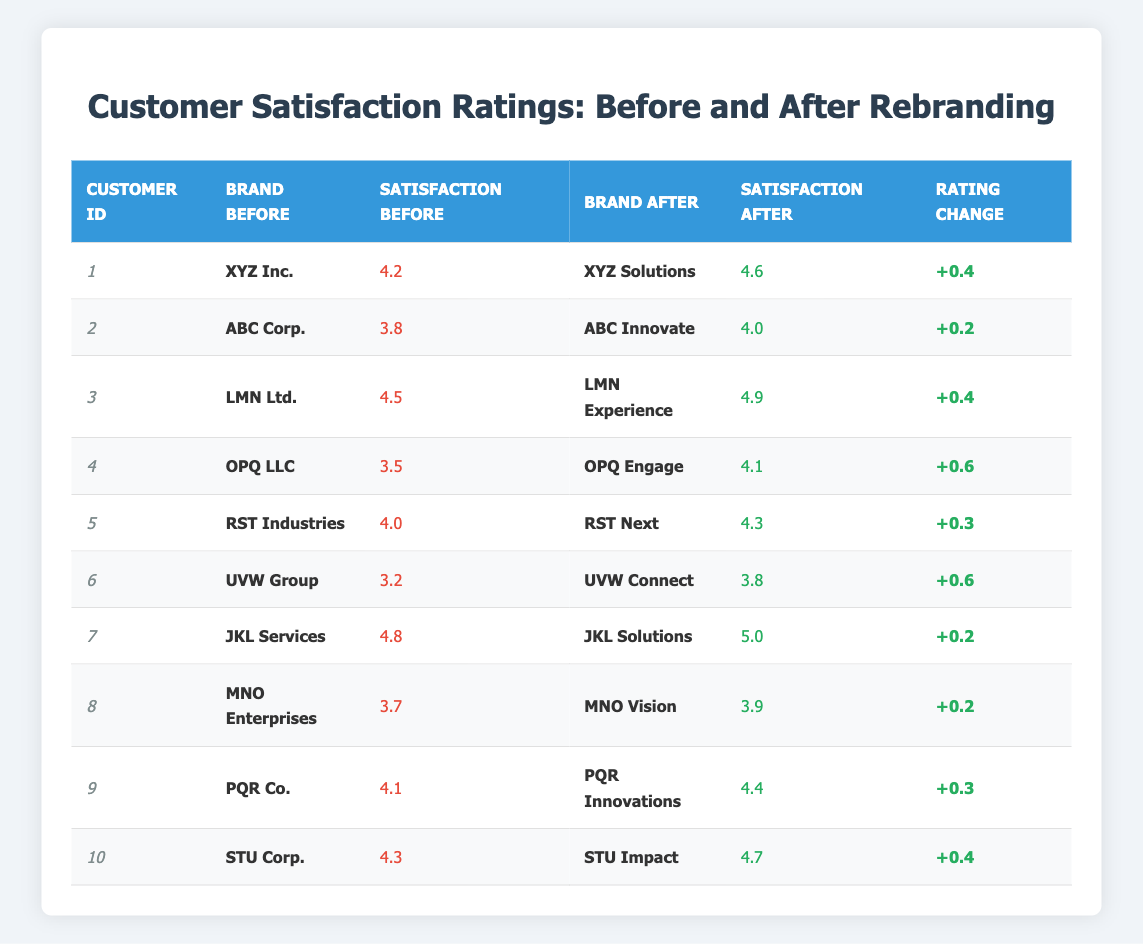What was the highest satisfaction rating before rebranding? The highest satisfaction rating before rebranding can be found by looking at the "Satisfaction Rating Before" column. Scanning through the values, the highest is 4.8 (Customer 7).
Answer: 4.8 What was the brand after rebranding for Customer 4? The table shows the brand before and after rebranding, and for Customer 4, the brand after rebranding is "OPQ Engage."
Answer: OPQ Engage How many customers had a satisfaction rating increase greater than 0.3? To find this, we look at the "Rating Change" column. The changes greater than 0.3 are for Customers 1, 3, 4, 5, 6, 9, and 10, making a total of 7 customers.
Answer: 7 Is there any customer whose satisfaction rating decreased after rebranding? We need to check the "Satisfaction Rating After" against "Satisfaction Rating Before." Customer 6 has a decrease from 3.2 to 3.8, showing a positive change, indicating no customer had a decrease.
Answer: No What is the average satisfaction rating before rebranding? We sum all the satisfaction ratings before rebranding: (4.2 + 3.8 + 4.5 + 3.5 + 4.0 + 3.2 + 4.8 + 3.7 + 4.1 + 4.3) = 43.1. Dividing by 10 customers gives us an average of 4.31.
Answer: 4.31 What was the rating change for the customer with the lowest rating before rebranding? The customer with the lowest rating before rebranding is Customer 6, who had a rating of 3.2. The change for this customer, as per the "Rating Change" column, is +0.6.
Answer: +0.6 How much did Customer 5's satisfaction rating increase? For Customer 5, the satisfaction rating before rebranding was 4.0 and after it became 4.3. The change is calculated as 4.3 - 4.0 = 0.3.
Answer: 0.3 Which brand after rebranding had the highest satisfaction rating? We refer to the "Satisfaction Rating After" column and find the highest value, which is 5.0 for "JKL Solutions" (Customer 7).
Answer: JKL Solutions How many customers rated less than 4.0 before rebranding? We count the ratings below 4.0 in the "Satisfaction Rating Before" column. Customers 4 (3.5), 6 (3.2), and 8 (3.7) fit this criterion, totaling 3 customers.
Answer: 3 What percentage of customers had a satisfaction rating after rebranding of 4.5 or above? There are 10 customers, and those with ratings of 4.5 or above after rebranding are Customers 3 (4.9), 7 (5.0), 9 (4.4), and 10 (4.7), totaling 4. The percentage is (4/10) * 100 = 40%.
Answer: 40% 